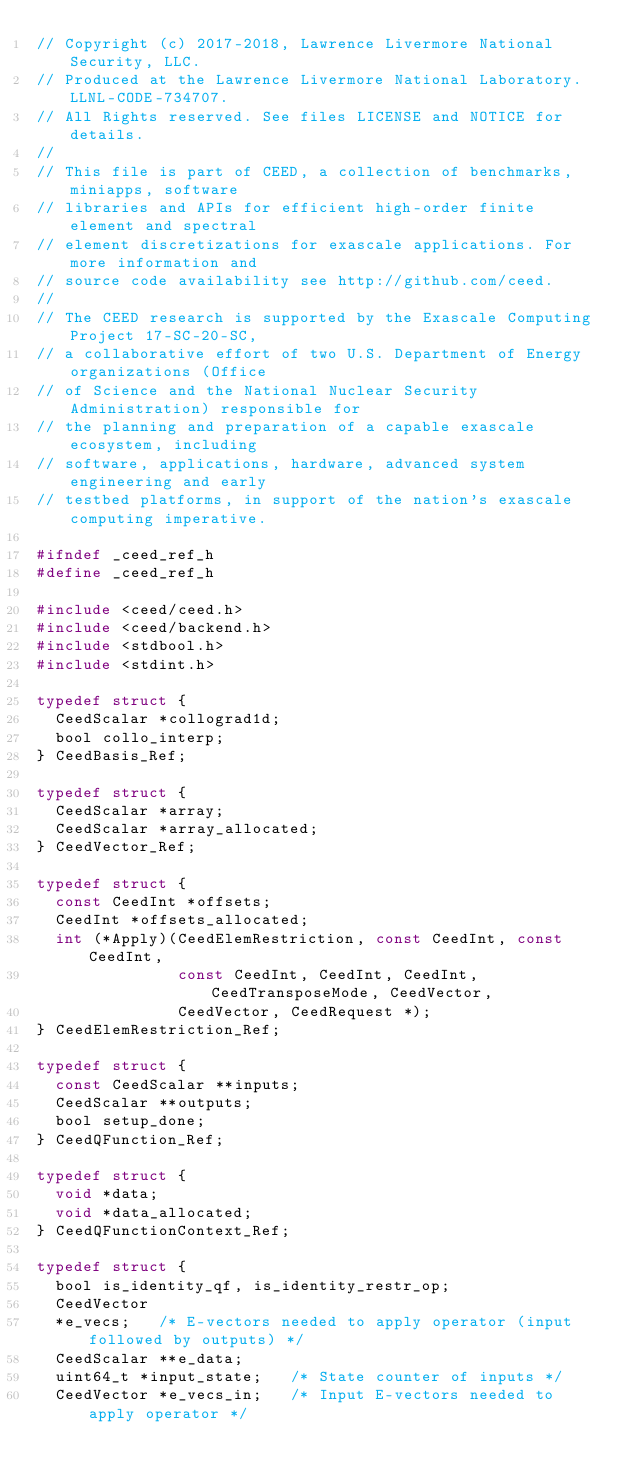Convert code to text. <code><loc_0><loc_0><loc_500><loc_500><_C_>// Copyright (c) 2017-2018, Lawrence Livermore National Security, LLC.
// Produced at the Lawrence Livermore National Laboratory. LLNL-CODE-734707.
// All Rights reserved. See files LICENSE and NOTICE for details.
//
// This file is part of CEED, a collection of benchmarks, miniapps, software
// libraries and APIs for efficient high-order finite element and spectral
// element discretizations for exascale applications. For more information and
// source code availability see http://github.com/ceed.
//
// The CEED research is supported by the Exascale Computing Project 17-SC-20-SC,
// a collaborative effort of two U.S. Department of Energy organizations (Office
// of Science and the National Nuclear Security Administration) responsible for
// the planning and preparation of a capable exascale ecosystem, including
// software, applications, hardware, advanced system engineering and early
// testbed platforms, in support of the nation's exascale computing imperative.

#ifndef _ceed_ref_h
#define _ceed_ref_h

#include <ceed/ceed.h>
#include <ceed/backend.h>
#include <stdbool.h>
#include <stdint.h>

typedef struct {
  CeedScalar *collograd1d;
  bool collo_interp;
} CeedBasis_Ref;

typedef struct {
  CeedScalar *array;
  CeedScalar *array_allocated;
} CeedVector_Ref;

typedef struct {
  const CeedInt *offsets;
  CeedInt *offsets_allocated;
  int (*Apply)(CeedElemRestriction, const CeedInt, const CeedInt,
               const CeedInt, CeedInt, CeedInt, CeedTransposeMode, CeedVector,
               CeedVector, CeedRequest *);
} CeedElemRestriction_Ref;

typedef struct {
  const CeedScalar **inputs;
  CeedScalar **outputs;
  bool setup_done;
} CeedQFunction_Ref;

typedef struct {
  void *data;
  void *data_allocated;
} CeedQFunctionContext_Ref;

typedef struct {
  bool is_identity_qf, is_identity_restr_op;
  CeedVector
  *e_vecs;   /* E-vectors needed to apply operator (input followed by outputs) */
  CeedScalar **e_data;
  uint64_t *input_state;   /* State counter of inputs */
  CeedVector *e_vecs_in;   /* Input E-vectors needed to apply operator */</code> 